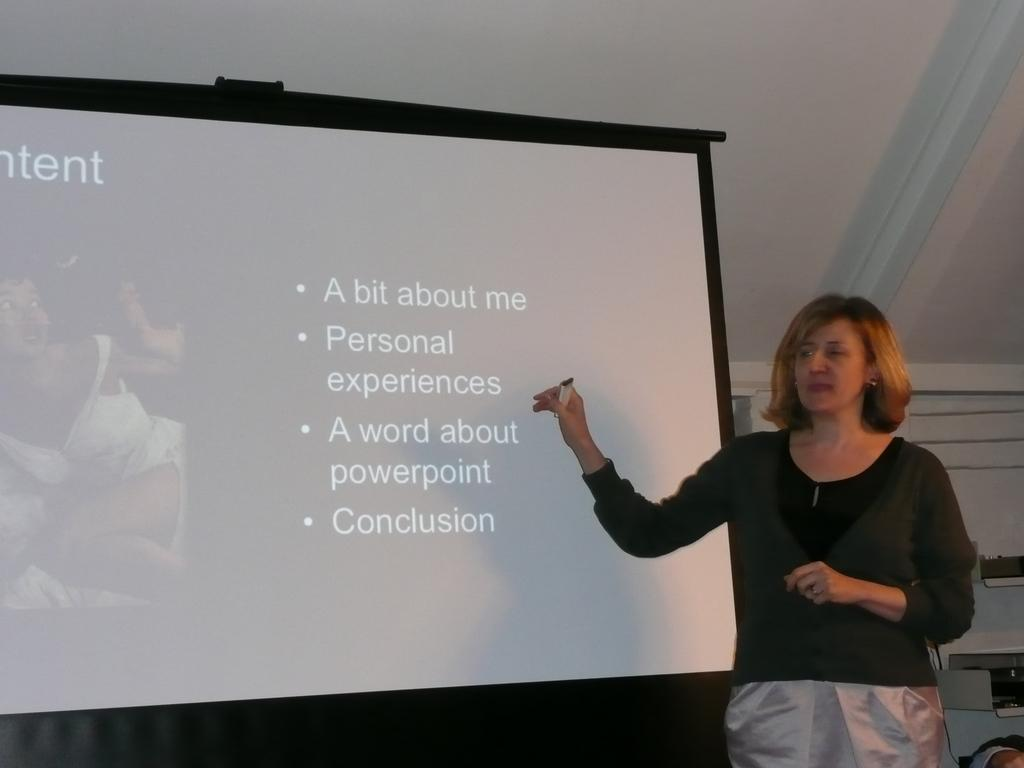What is present in the image? There is a woman in the image. What is the woman holding in the image? The woman is holding an object. Can you describe another element in the image? There is a screen in the image. How many rings can be seen on the woman's fingers in the image? There is no information about rings on the woman's fingers in the image. Is there a band playing on the screen in the image? There is no information about a band or any music-related content on the screen in the image. 